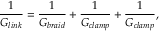<formula> <loc_0><loc_0><loc_500><loc_500>\frac { 1 } { G _ { l i n k } } = \frac { 1 } { G _ { b r a i d } } + \frac { 1 } { G _ { c l a m p } } + \frac { 1 } { G _ { c l a m p } } ,</formula> 